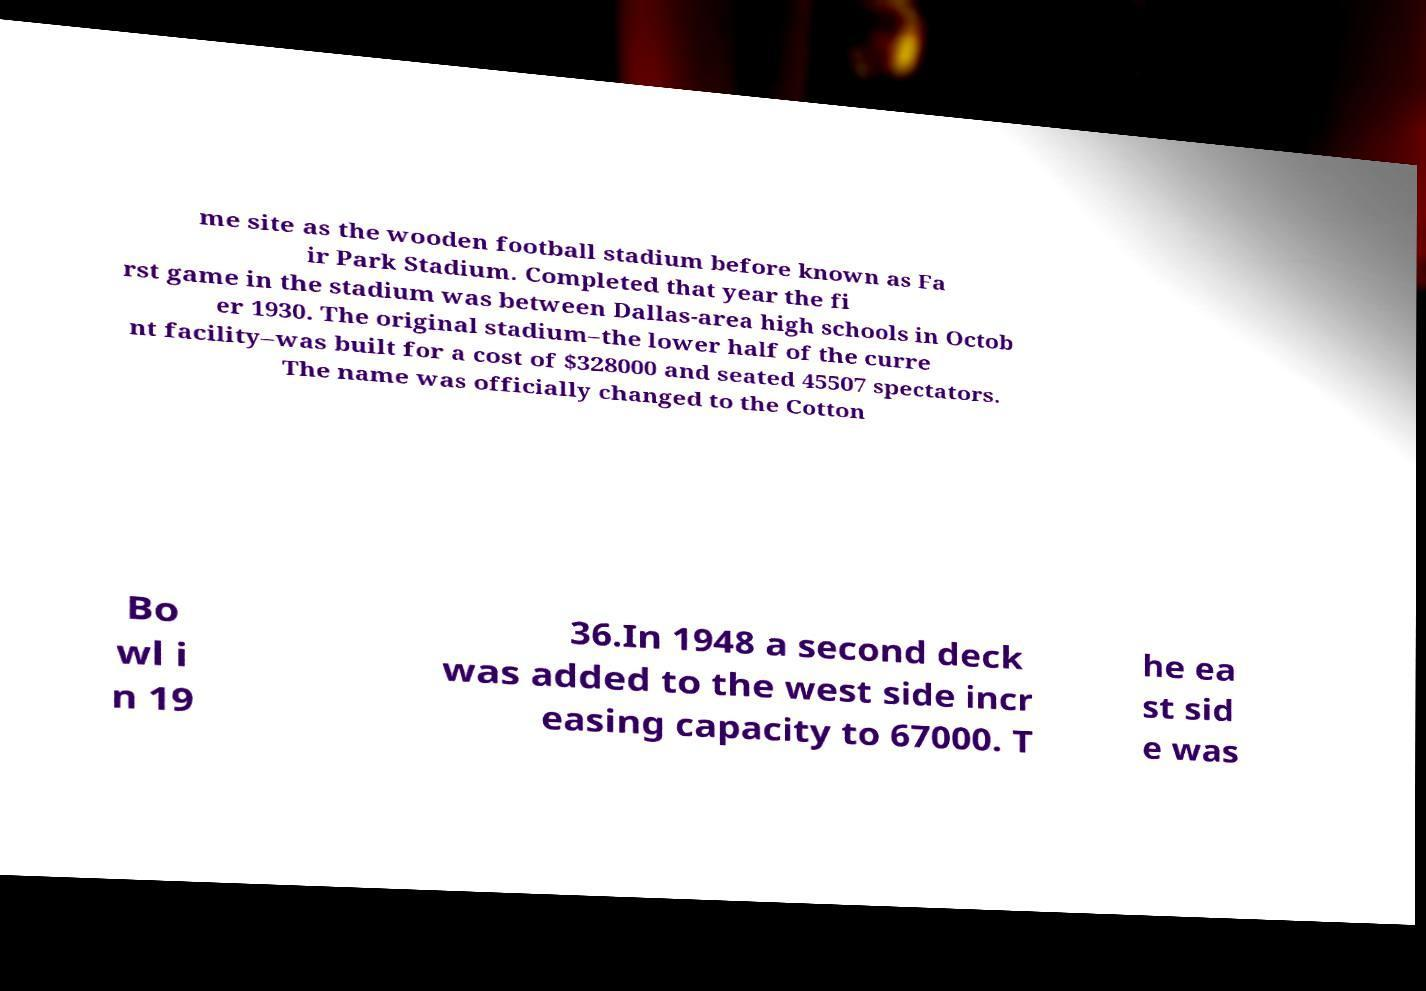Could you extract and type out the text from this image? me site as the wooden football stadium before known as Fa ir Park Stadium. Completed that year the fi rst game in the stadium was between Dallas-area high schools in Octob er 1930. The original stadium–the lower half of the curre nt facility–was built for a cost of $328000 and seated 45507 spectators. The name was officially changed to the Cotton Bo wl i n 19 36.In 1948 a second deck was added to the west side incr easing capacity to 67000. T he ea st sid e was 